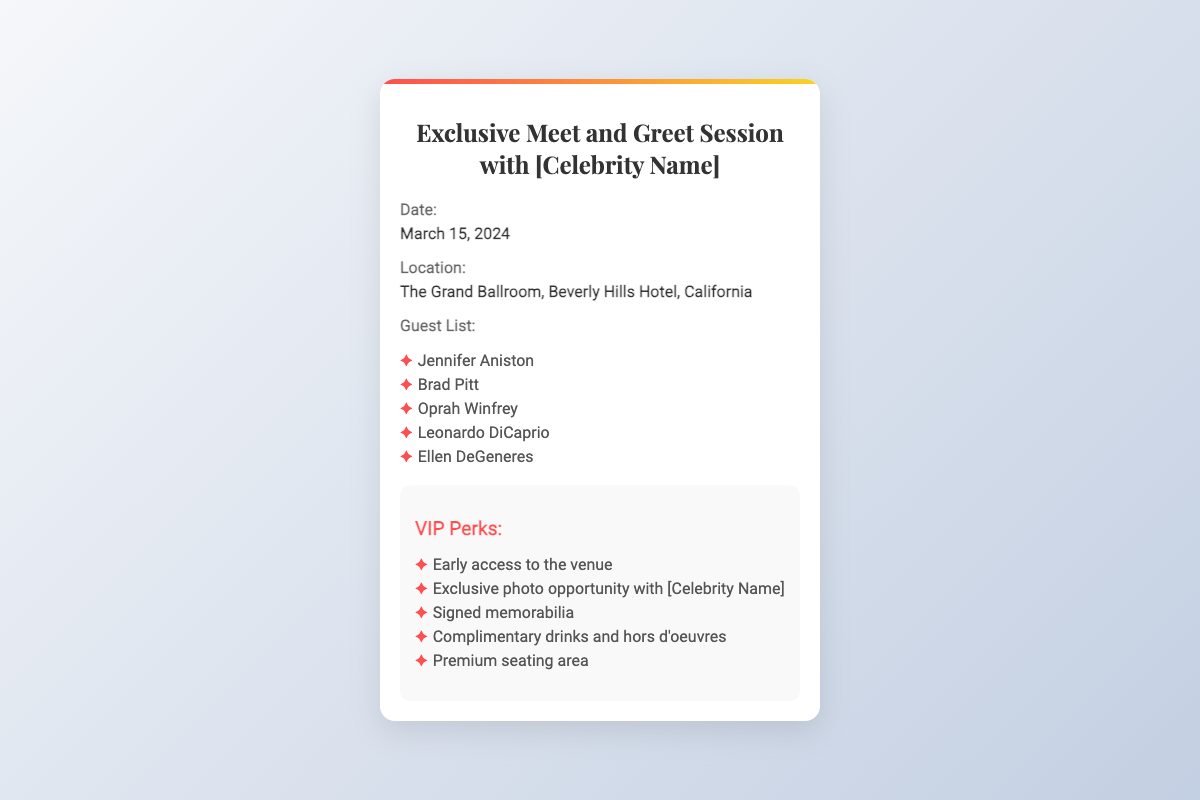What is the date of the event? The date can be found under the "Date" section of the document, which states March 15, 2024.
Answer: March 15, 2024 Where is the event taking place? The location is specified in the "Location" section, indicating The Grand Ballroom, Beverly Hills Hotel, California.
Answer: The Grand Ballroom, Beverly Hills Hotel, California Who is one of the guests listed? The "Guest List" section provides names of attendees, one of whom is Jennifer Aniston.
Answer: Jennifer Aniston What is one of the VIP perks? The document lists several VIP perks, including early access to the venue.
Answer: Early access to the venue How many guests are listed in total? The number of persons in the "Guest List" section can be counted; there are five names mentioned.
Answer: Five What type of event is this ticket for? The title of the ticket indicates that it is for an Exclusive Meet and Greet Session with a celebrity.
Answer: Exclusive Meet and Greet Session Is there complimentary food at the event? The "VIP Perks" section mentions complimentary drinks and hors d'oeuvres, indicating food will be provided.
Answer: Yes What will attendees get with an exclusive photo opportunity? The phrase indicates that attendees will have a chance to take a photo with the celebrity, which is a perk.
Answer: Photo opportunity with [Celebrity Name] What is the background color of the ticket? The background of the ticket is light-colored, as specified in the visual design elements of the document.
Answer: White 